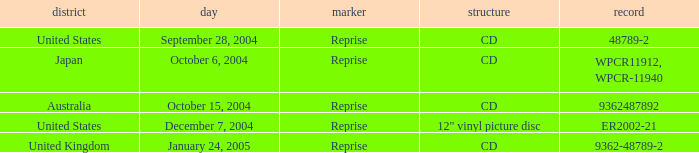What is the catalogue on october 15, 2004? 9362487892.0. 